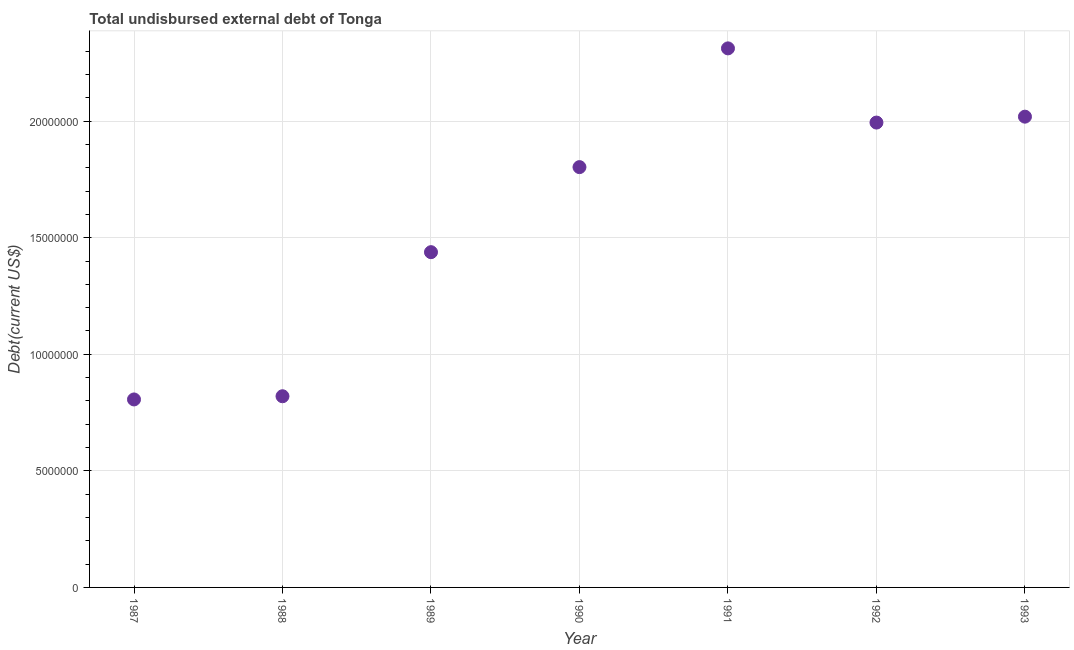What is the total debt in 1991?
Offer a terse response. 2.31e+07. Across all years, what is the maximum total debt?
Keep it short and to the point. 2.31e+07. Across all years, what is the minimum total debt?
Provide a short and direct response. 8.06e+06. In which year was the total debt minimum?
Give a very brief answer. 1987. What is the sum of the total debt?
Offer a very short reply. 1.12e+08. What is the difference between the total debt in 1987 and 1993?
Provide a short and direct response. -1.21e+07. What is the average total debt per year?
Offer a very short reply. 1.60e+07. What is the median total debt?
Ensure brevity in your answer.  1.80e+07. In how many years, is the total debt greater than 14000000 US$?
Ensure brevity in your answer.  5. Do a majority of the years between 1993 and 1991 (inclusive) have total debt greater than 7000000 US$?
Offer a very short reply. No. What is the ratio of the total debt in 1992 to that in 1993?
Provide a short and direct response. 0.99. Is the difference between the total debt in 1987 and 1993 greater than the difference between any two years?
Your answer should be compact. No. What is the difference between the highest and the second highest total debt?
Ensure brevity in your answer.  2.93e+06. Is the sum of the total debt in 1987 and 1990 greater than the maximum total debt across all years?
Your response must be concise. Yes. What is the difference between the highest and the lowest total debt?
Keep it short and to the point. 1.51e+07. In how many years, is the total debt greater than the average total debt taken over all years?
Offer a terse response. 4. Does the total debt monotonically increase over the years?
Your response must be concise. No. How many dotlines are there?
Offer a terse response. 1. What is the title of the graph?
Make the answer very short. Total undisbursed external debt of Tonga. What is the label or title of the Y-axis?
Provide a short and direct response. Debt(current US$). What is the Debt(current US$) in 1987?
Offer a very short reply. 8.06e+06. What is the Debt(current US$) in 1988?
Your answer should be very brief. 8.20e+06. What is the Debt(current US$) in 1989?
Give a very brief answer. 1.44e+07. What is the Debt(current US$) in 1990?
Give a very brief answer. 1.80e+07. What is the Debt(current US$) in 1991?
Offer a terse response. 2.31e+07. What is the Debt(current US$) in 1992?
Give a very brief answer. 1.99e+07. What is the Debt(current US$) in 1993?
Your answer should be very brief. 2.02e+07. What is the difference between the Debt(current US$) in 1987 and 1988?
Your answer should be compact. -1.37e+05. What is the difference between the Debt(current US$) in 1987 and 1989?
Provide a succinct answer. -6.32e+06. What is the difference between the Debt(current US$) in 1987 and 1990?
Offer a very short reply. -9.96e+06. What is the difference between the Debt(current US$) in 1987 and 1991?
Your answer should be very brief. -1.51e+07. What is the difference between the Debt(current US$) in 1987 and 1992?
Your answer should be very brief. -1.19e+07. What is the difference between the Debt(current US$) in 1987 and 1993?
Ensure brevity in your answer.  -1.21e+07. What is the difference between the Debt(current US$) in 1988 and 1989?
Offer a very short reply. -6.18e+06. What is the difference between the Debt(current US$) in 1988 and 1990?
Your response must be concise. -9.83e+06. What is the difference between the Debt(current US$) in 1988 and 1991?
Your answer should be compact. -1.49e+07. What is the difference between the Debt(current US$) in 1988 and 1992?
Your response must be concise. -1.17e+07. What is the difference between the Debt(current US$) in 1988 and 1993?
Your response must be concise. -1.20e+07. What is the difference between the Debt(current US$) in 1989 and 1990?
Ensure brevity in your answer.  -3.65e+06. What is the difference between the Debt(current US$) in 1989 and 1991?
Keep it short and to the point. -8.74e+06. What is the difference between the Debt(current US$) in 1989 and 1992?
Provide a succinct answer. -5.56e+06. What is the difference between the Debt(current US$) in 1989 and 1993?
Keep it short and to the point. -5.81e+06. What is the difference between the Debt(current US$) in 1990 and 1991?
Ensure brevity in your answer.  -5.09e+06. What is the difference between the Debt(current US$) in 1990 and 1992?
Your answer should be compact. -1.91e+06. What is the difference between the Debt(current US$) in 1990 and 1993?
Your answer should be very brief. -2.16e+06. What is the difference between the Debt(current US$) in 1991 and 1992?
Ensure brevity in your answer.  3.18e+06. What is the difference between the Debt(current US$) in 1991 and 1993?
Offer a very short reply. 2.93e+06. What is the difference between the Debt(current US$) in 1992 and 1993?
Offer a very short reply. -2.53e+05. What is the ratio of the Debt(current US$) in 1987 to that in 1989?
Make the answer very short. 0.56. What is the ratio of the Debt(current US$) in 1987 to that in 1990?
Make the answer very short. 0.45. What is the ratio of the Debt(current US$) in 1987 to that in 1991?
Keep it short and to the point. 0.35. What is the ratio of the Debt(current US$) in 1987 to that in 1992?
Ensure brevity in your answer.  0.4. What is the ratio of the Debt(current US$) in 1987 to that in 1993?
Your response must be concise. 0.4. What is the ratio of the Debt(current US$) in 1988 to that in 1989?
Give a very brief answer. 0.57. What is the ratio of the Debt(current US$) in 1988 to that in 1990?
Offer a very short reply. 0.46. What is the ratio of the Debt(current US$) in 1988 to that in 1991?
Ensure brevity in your answer.  0.35. What is the ratio of the Debt(current US$) in 1988 to that in 1992?
Your answer should be very brief. 0.41. What is the ratio of the Debt(current US$) in 1988 to that in 1993?
Offer a very short reply. 0.41. What is the ratio of the Debt(current US$) in 1989 to that in 1990?
Ensure brevity in your answer.  0.8. What is the ratio of the Debt(current US$) in 1989 to that in 1991?
Offer a terse response. 0.62. What is the ratio of the Debt(current US$) in 1989 to that in 1992?
Provide a succinct answer. 0.72. What is the ratio of the Debt(current US$) in 1989 to that in 1993?
Keep it short and to the point. 0.71. What is the ratio of the Debt(current US$) in 1990 to that in 1991?
Provide a succinct answer. 0.78. What is the ratio of the Debt(current US$) in 1990 to that in 1992?
Your answer should be compact. 0.9. What is the ratio of the Debt(current US$) in 1990 to that in 1993?
Provide a short and direct response. 0.89. What is the ratio of the Debt(current US$) in 1991 to that in 1992?
Provide a succinct answer. 1.16. What is the ratio of the Debt(current US$) in 1991 to that in 1993?
Your answer should be compact. 1.15. 